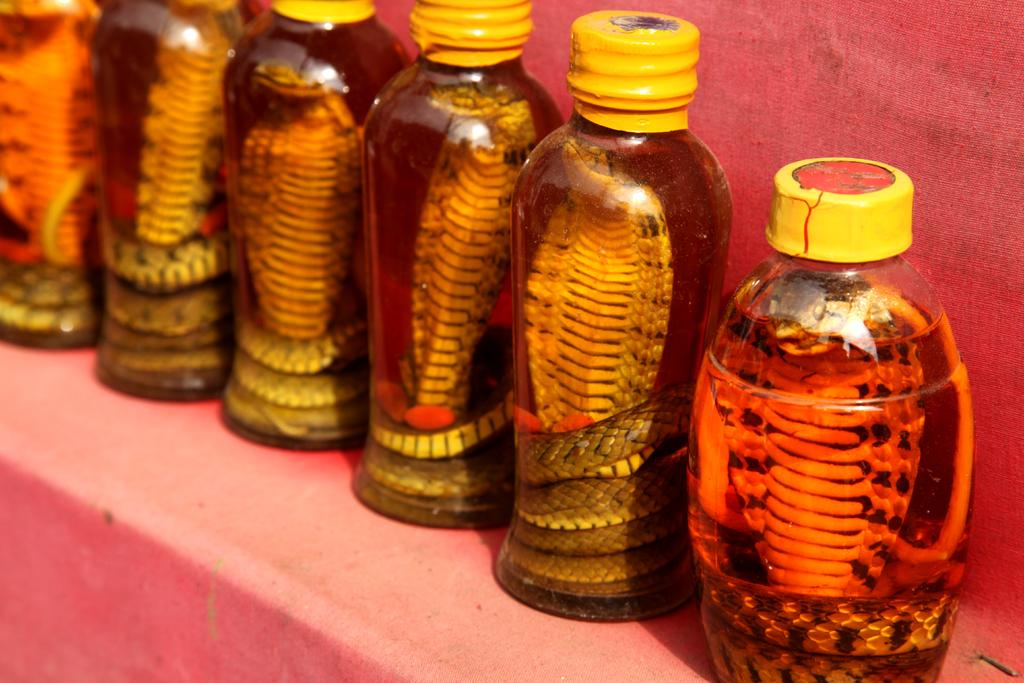What is the main subject of the image? The main subject of the image is many bottles. What is inside the bottles? There are snakes inside the bottles. What type of insect can be seen crawling on the table in the image? There is no table or insect present in the image; it only features bottles with snakes inside. 